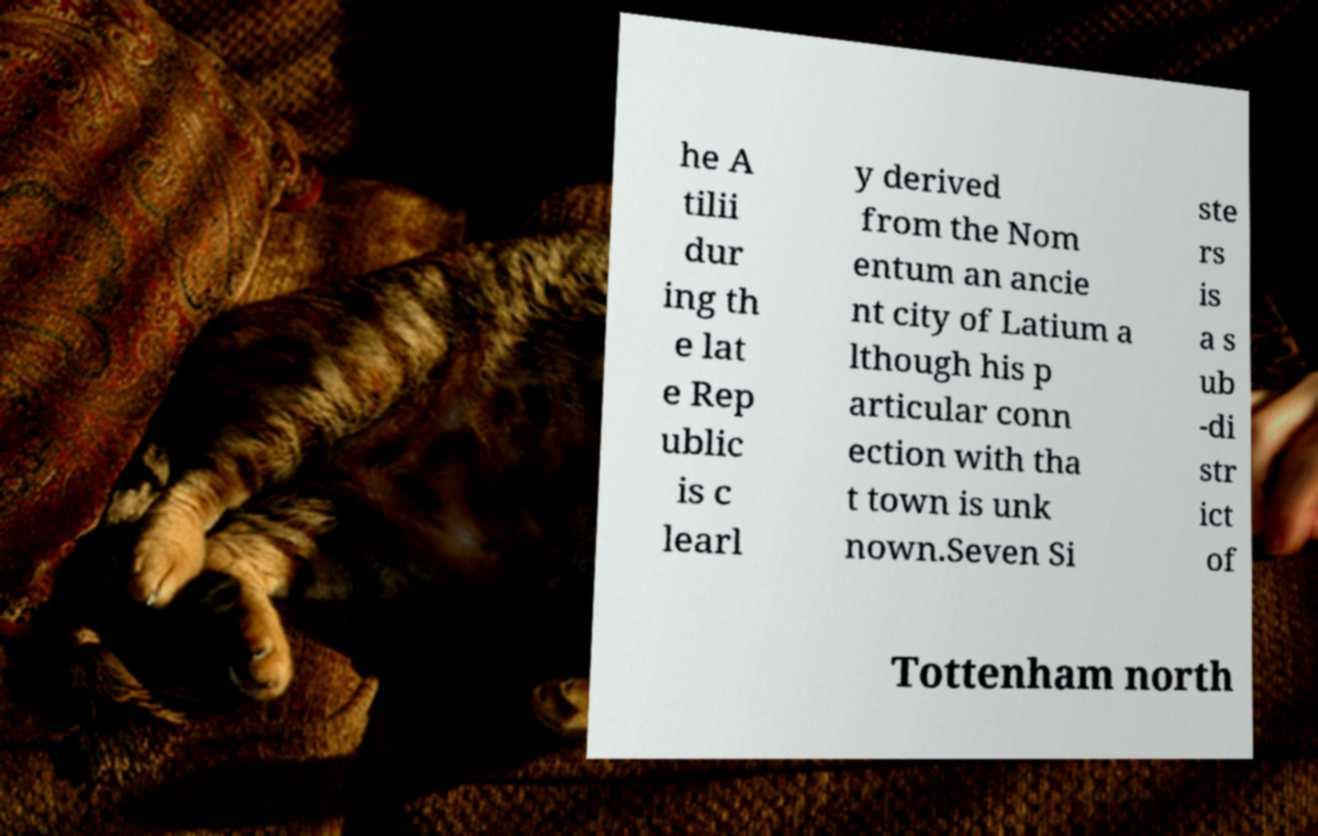Could you extract and type out the text from this image? he A tilii dur ing th e lat e Rep ublic is c learl y derived from the Nom entum an ancie nt city of Latium a lthough his p articular conn ection with tha t town is unk nown.Seven Si ste rs is a s ub -di str ict of Tottenham north 